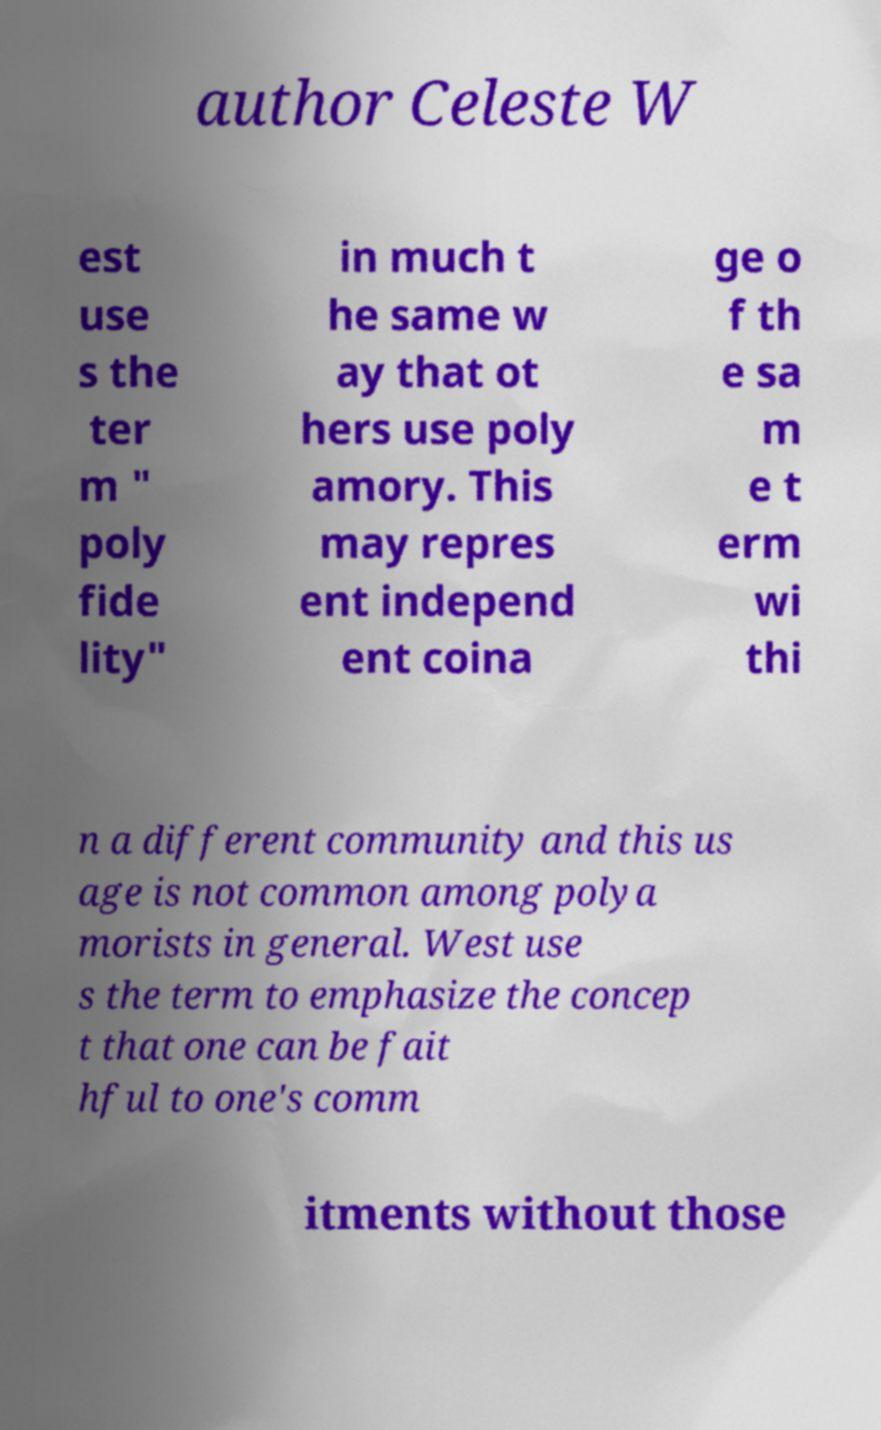Please identify and transcribe the text found in this image. author Celeste W est use s the ter m " poly fide lity" in much t he same w ay that ot hers use poly amory. This may repres ent independ ent coina ge o f th e sa m e t erm wi thi n a different community and this us age is not common among polya morists in general. West use s the term to emphasize the concep t that one can be fait hful to one's comm itments without those 